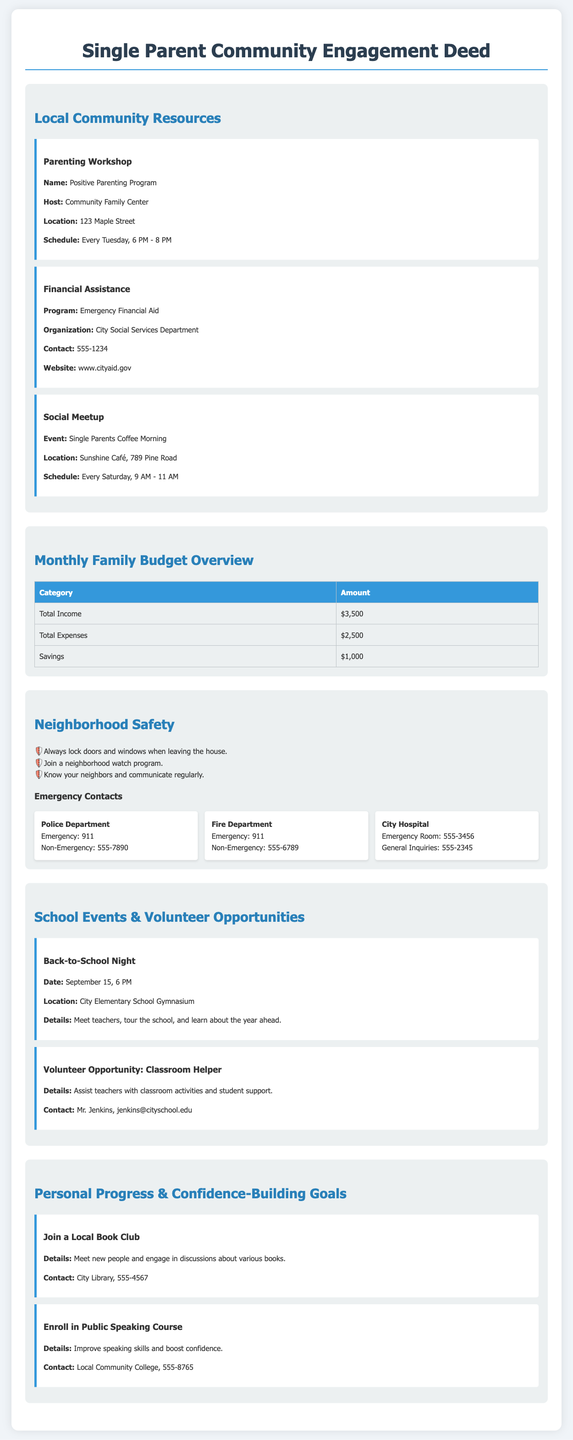What is the name of the parenting workshop? The name of the parenting workshop is mentioned in the resources section as the "Positive Parenting Program."
Answer: Positive Parenting Program What is the location of the financial assistance program? The location of the financial assistance program is specified as the City Social Services Department, which is contacted via the number provided in the document.
Answer: City Social Services Department How often does the Single Parents Coffee Morning occur? The frequency of the Single Parents Coffee Morning is detailed in the resources section, indicating it occurs every Saturday.
Answer: Every Saturday What is the total income reported for the month? The total income is provided in the budget overview section as $3,500.
Answer: $3,500 How many safety tips are listed in the neighborhood safety section? The number of safety tips can be determined by counting the items listed in the neighborhood safety section, which shows three tips.
Answer: Three What is the date of the Back-to-School Night event? The date for the Back-to-School Night event is provided in the events section as September 15.
Answer: September 15 Which organization provides the Public Speaking Course? The organization that offers the Public Speaking Course is mentioned as the Local Community College.
Answer: Local Community College How many emergency contacts are listed in the directory? The count of emergency contacts is found by reviewing the section, which shows there are three contacts listed.
Answer: Three What type of document is this? The document type is identified as a "Deed" for community engagement for single parents.
Answer: Deed 